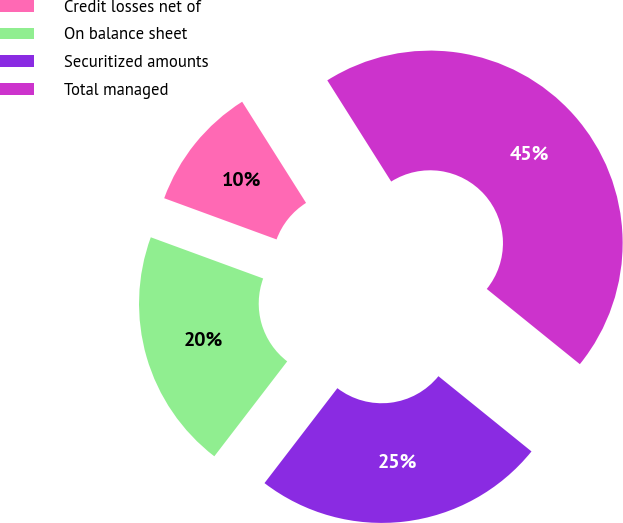Convert chart. <chart><loc_0><loc_0><loc_500><loc_500><pie_chart><fcel>Credit losses net of<fcel>On balance sheet<fcel>Securitized amounts<fcel>Total managed<nl><fcel>10.44%<fcel>20.17%<fcel>24.6%<fcel>44.78%<nl></chart> 